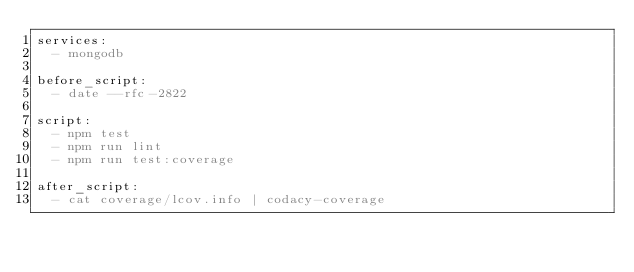Convert code to text. <code><loc_0><loc_0><loc_500><loc_500><_YAML_>services:
  - mongodb

before_script:
  - date --rfc-2822

script:
  - npm test
  - npm run lint
  - npm run test:coverage

after_script:
  - cat coverage/lcov.info | codacy-coverage
</code> 